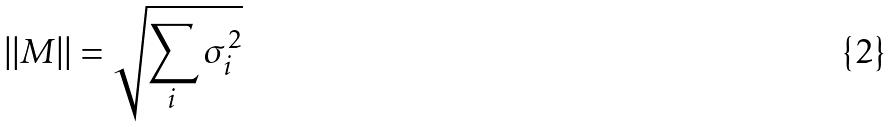<formula> <loc_0><loc_0><loc_500><loc_500>| | M | | = \sqrt { \sum _ { i } \sigma _ { i } ^ { 2 } }</formula> 